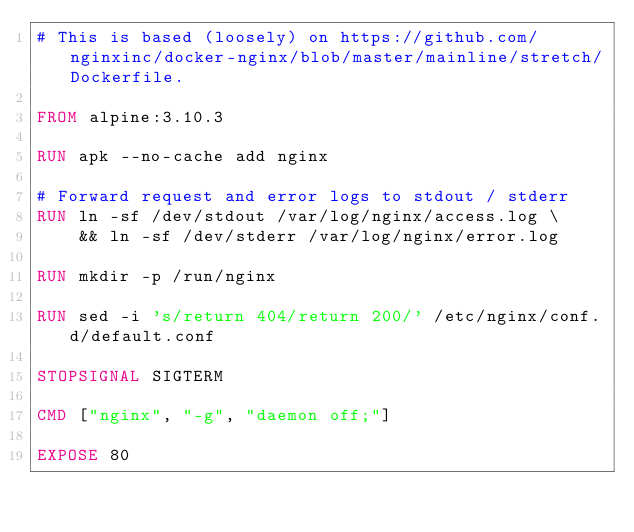<code> <loc_0><loc_0><loc_500><loc_500><_Dockerfile_># This is based (loosely) on https://github.com/nginxinc/docker-nginx/blob/master/mainline/stretch/Dockerfile.

FROM alpine:3.10.3

RUN apk --no-cache add nginx

# Forward request and error logs to stdout / stderr
RUN ln -sf /dev/stdout /var/log/nginx/access.log \
    && ln -sf /dev/stderr /var/log/nginx/error.log

RUN mkdir -p /run/nginx

RUN sed -i 's/return 404/return 200/' /etc/nginx/conf.d/default.conf

STOPSIGNAL SIGTERM

CMD ["nginx", "-g", "daemon off;"]

EXPOSE 80
</code> 